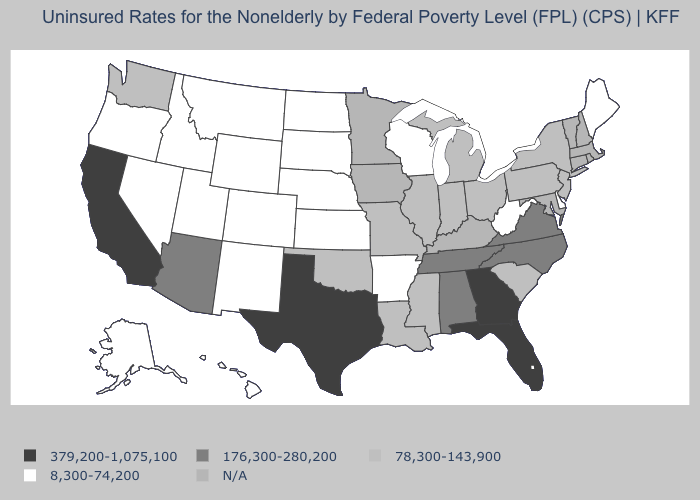Name the states that have a value in the range 379,200-1,075,100?
Quick response, please. California, Florida, Georgia, Texas. Which states have the highest value in the USA?
Quick response, please. California, Florida, Georgia, Texas. Does the first symbol in the legend represent the smallest category?
Keep it brief. No. What is the value of Maine?
Quick response, please. 8,300-74,200. What is the value of Nevada?
Keep it brief. 8,300-74,200. Name the states that have a value in the range 176,300-280,200?
Keep it brief. Alabama, Arizona, North Carolina, Tennessee, Virginia. What is the value of Utah?
Give a very brief answer. 8,300-74,200. What is the value of Oklahoma?
Concise answer only. 78,300-143,900. Name the states that have a value in the range 176,300-280,200?
Keep it brief. Alabama, Arizona, North Carolina, Tennessee, Virginia. Which states have the highest value in the USA?
Quick response, please. California, Florida, Georgia, Texas. What is the value of Louisiana?
Give a very brief answer. 78,300-143,900. What is the value of Massachusetts?
Keep it brief. N/A. 